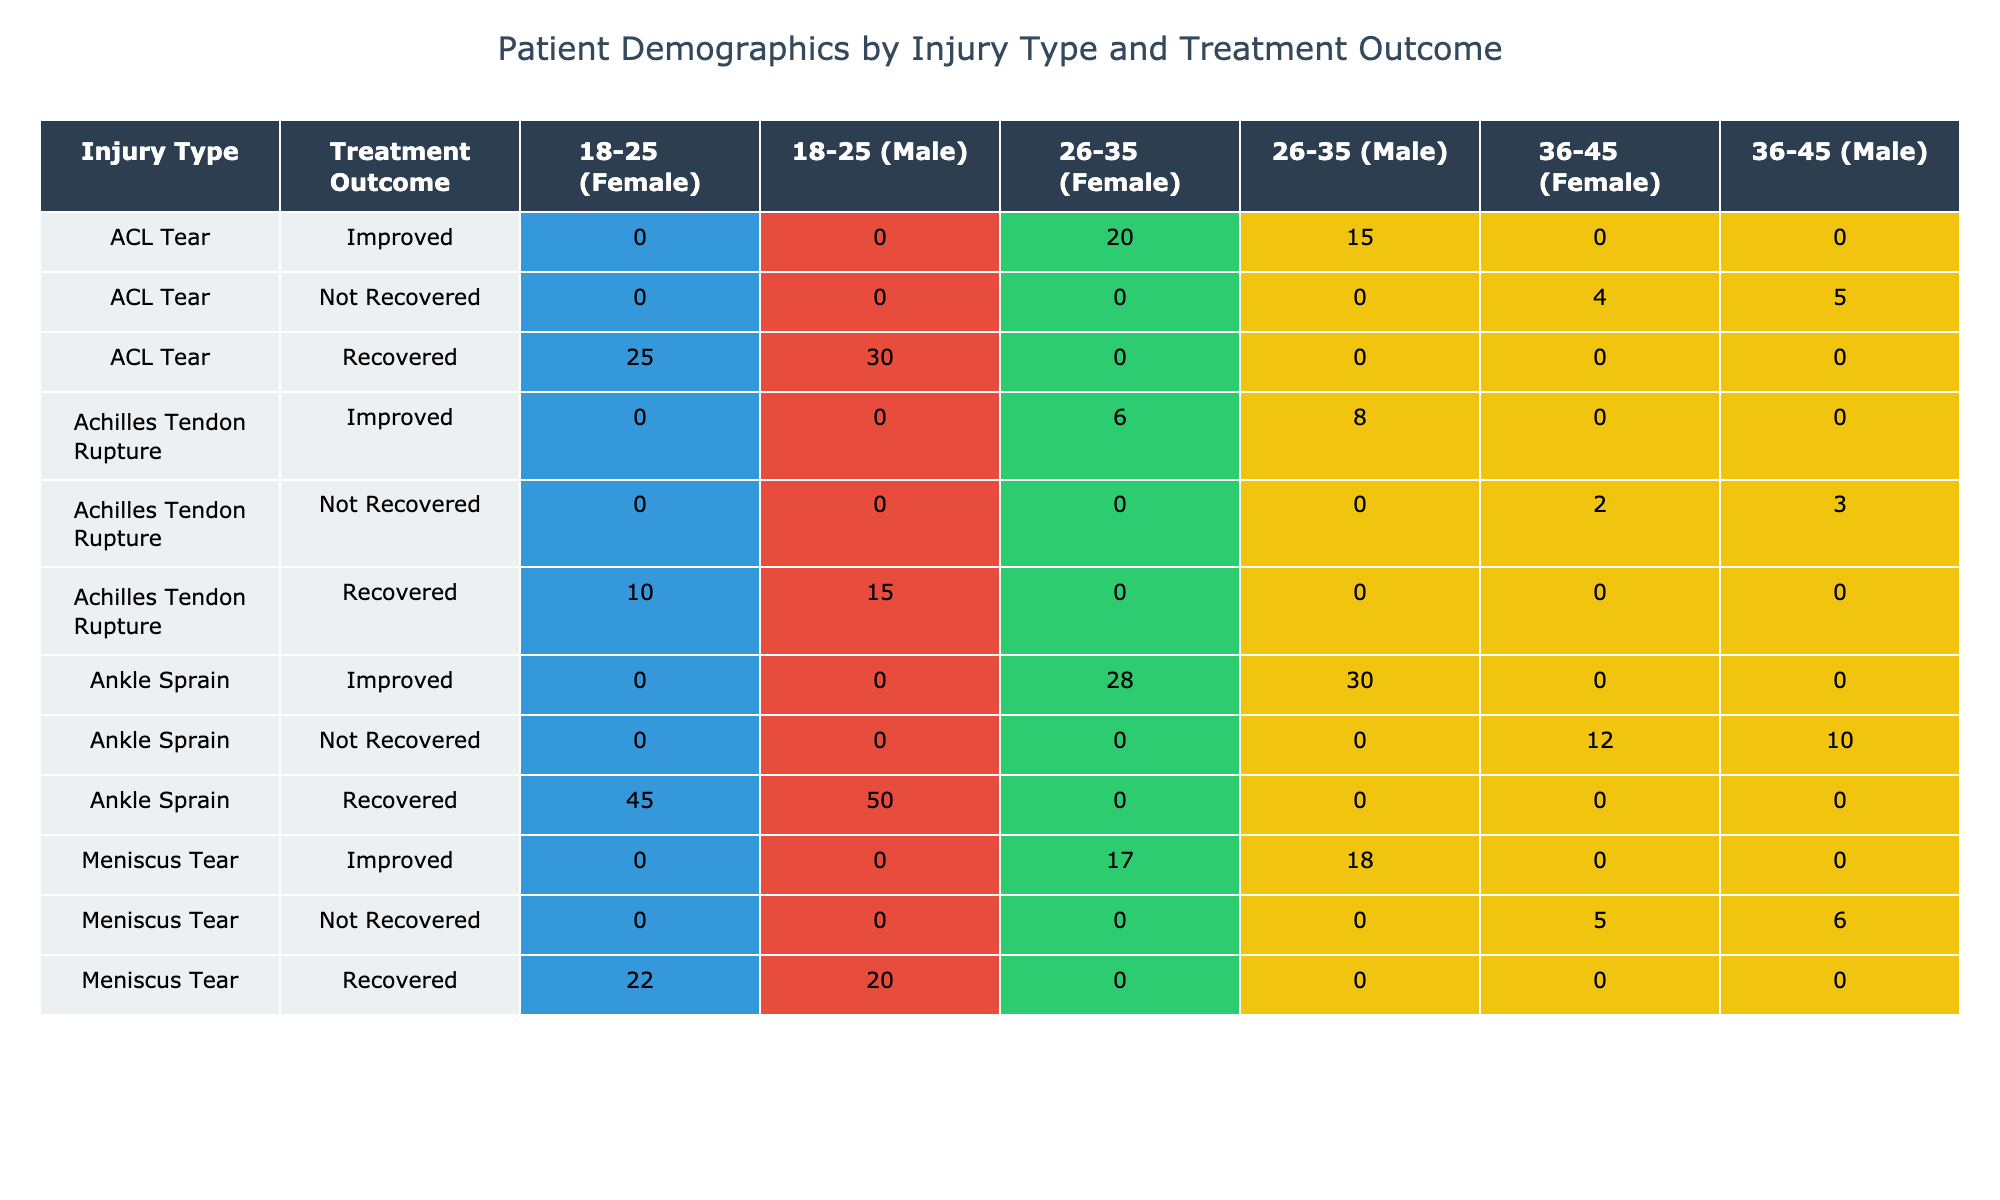What is the total number of patients with an ACL tear who recovered? Looking at the ACL tear section, there are 30 male patients and 25 female patients who recovered. Adding these together gives 30 + 25 = 55 patients.
Answer: 55 What percentage of male patients with ankle sprains improved? There are 50 male patients who recovered and 30 male patients who improved from the ankle sprain section. To find the percentage of males who improved, we take the number who improved (30) and divide it by the total number of males (50 + 30 = 80). Therefore, (30/80) * 100 = 37.5%.
Answer: 37.5% Did more females or males recover from meniscus tears? From the meniscus tear recovery section, 22 females and 20 males recovered. Comparing these values, 22 females is greater than 20 males, so more females recovered.
Answer: Yes What is the difference in the number of male patients with Achilles tendon ruptures who recovered versus those who improved? In the Achilles tendon rupture section, there are 15 male patients who recovered and 8 male patients who improved. The difference is 15 - 8 = 7.
Answer: 7 What is the total number of patients aged 26-35 who did not recover from ankle sprains? For ankle sprains, there are 10 males and 12 females aged 36-45 who did not recover. However, the question specifies 26-35. Looking at the pivot, there are no patients aged 26-35 listed who did not recover, which means the total is 0.
Answer: 0 What is the average number of patients who improved across all injury types for the age group 26-35? Looking at the injury types, we see 15 males and 20 females for ACL, 18 males and 17 females for meniscus, and 30 males and 28 females for ankle sprains. The total patients who improved are (15 + 20 + 18 + 17 + 30 + 28) = 128. There are six groups, so the average is 128 / 6 = approximately 21.33.
Answer: 21.33 